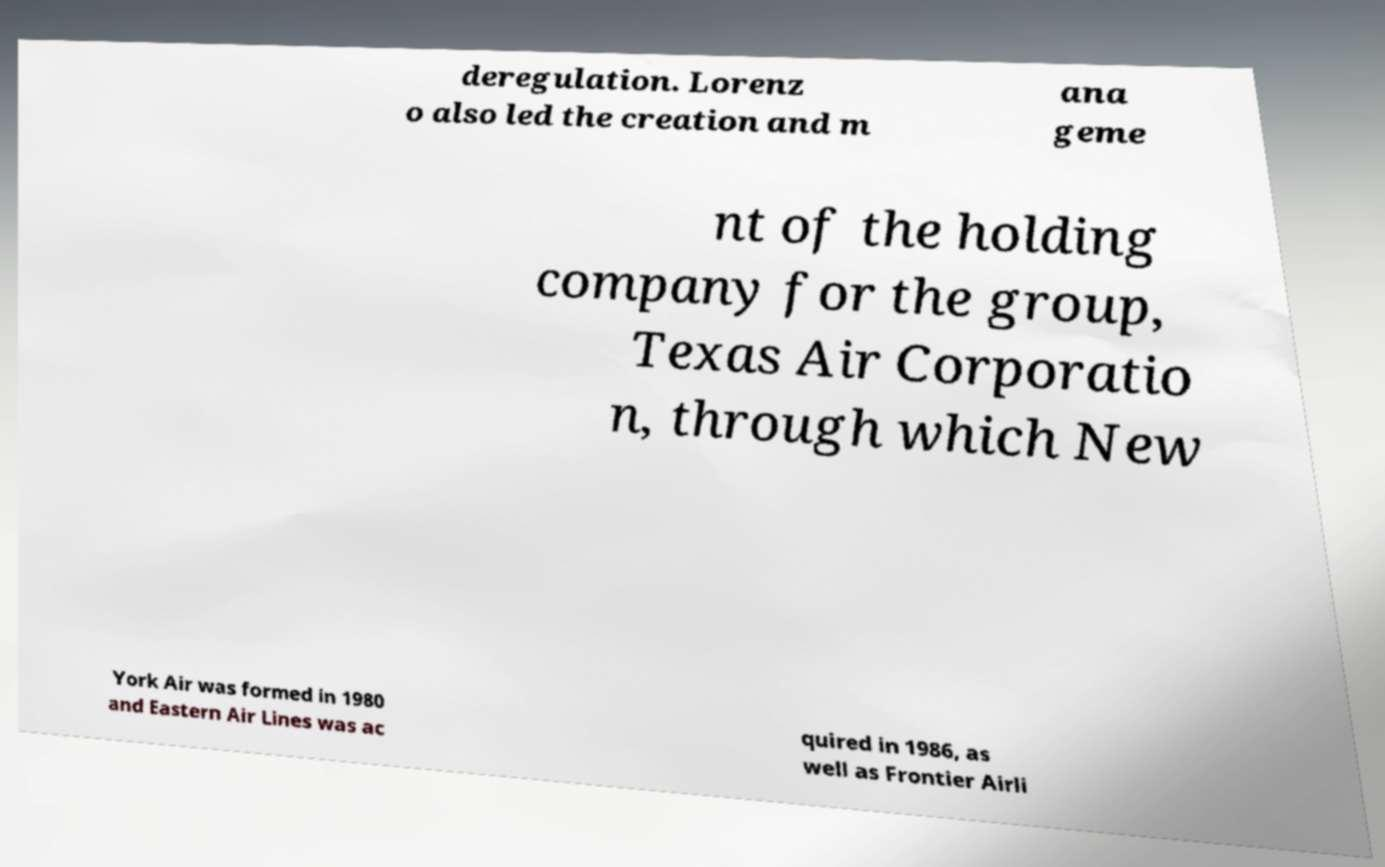Please identify and transcribe the text found in this image. deregulation. Lorenz o also led the creation and m ana geme nt of the holding company for the group, Texas Air Corporatio n, through which New York Air was formed in 1980 and Eastern Air Lines was ac quired in 1986, as well as Frontier Airli 